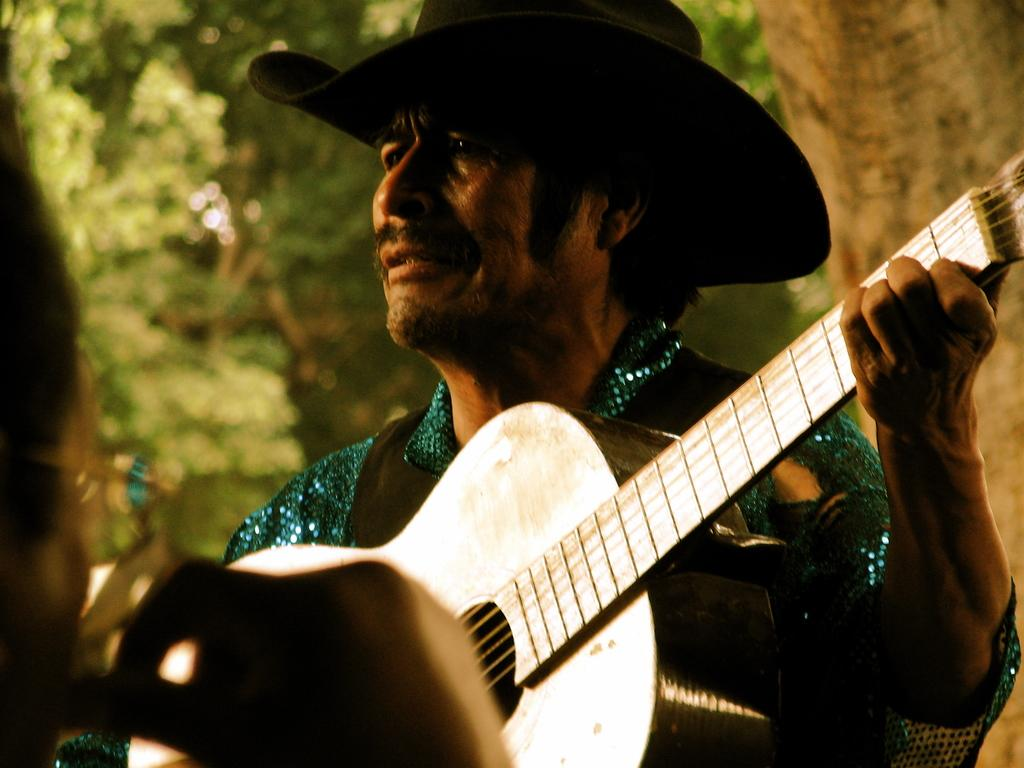What is the man in the image holding? The man is holding a guitar. What is the man doing with the guitar? The man is playing the guitar. What can be seen in the background of the image? There are trees in the background of the image. What shape is the guitar in the image? The provided facts do not mention the shape of the guitar, so it cannot be determined from the image. What does the guitar taste like in the image? The guitar is not an edible object, so it does not have a taste. 